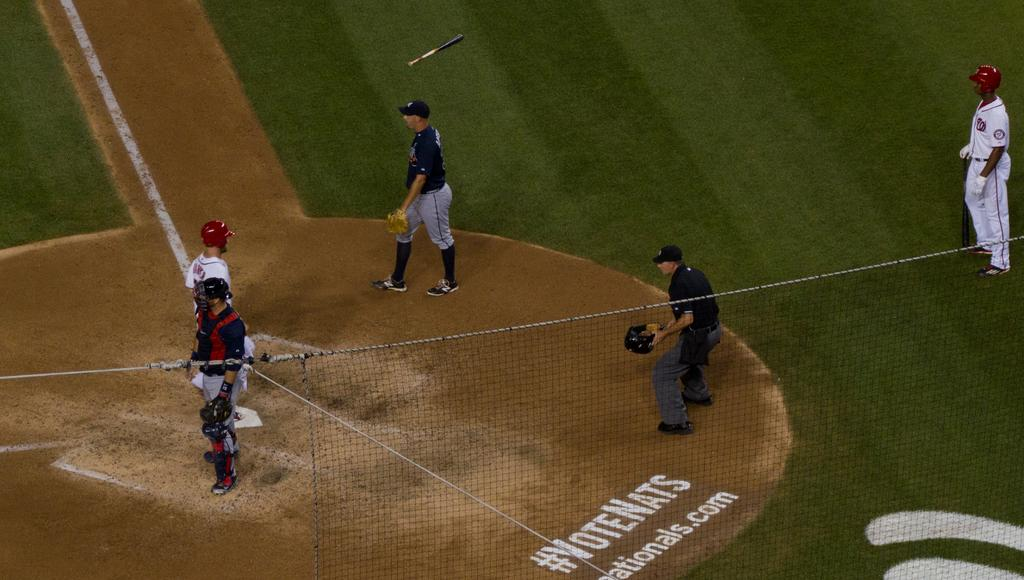Provide a one-sentence caption for the provided image. People playing baseball on a field that says "VoteNats". 